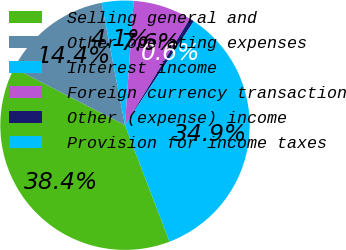<chart> <loc_0><loc_0><loc_500><loc_500><pie_chart><fcel>Selling general and<fcel>Other operating expenses<fcel>Interest income<fcel>Foreign currency transaction<fcel>Other (expense) income<fcel>Provision for income taxes<nl><fcel>38.38%<fcel>14.43%<fcel>4.11%<fcel>7.61%<fcel>0.6%<fcel>34.87%<nl></chart> 